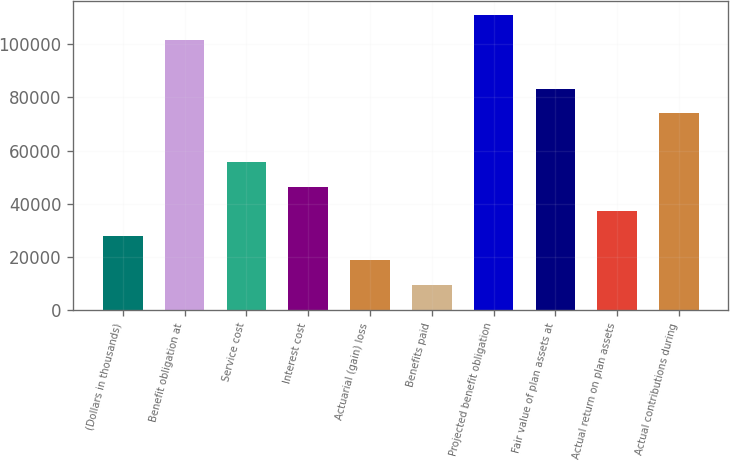Convert chart to OTSL. <chart><loc_0><loc_0><loc_500><loc_500><bar_chart><fcel>(Dollars in thousands)<fcel>Benefit obligation at<fcel>Service cost<fcel>Interest cost<fcel>Actuarial (gain) loss<fcel>Benefits paid<fcel>Projected benefit obligation<fcel>Fair value of plan assets at<fcel>Actual return on plan assets<fcel>Actual contributions during<nl><fcel>28012.9<fcel>101647<fcel>55625.8<fcel>46421.5<fcel>18808.6<fcel>9604.3<fcel>110852<fcel>83238.7<fcel>37217.2<fcel>74034.4<nl></chart> 